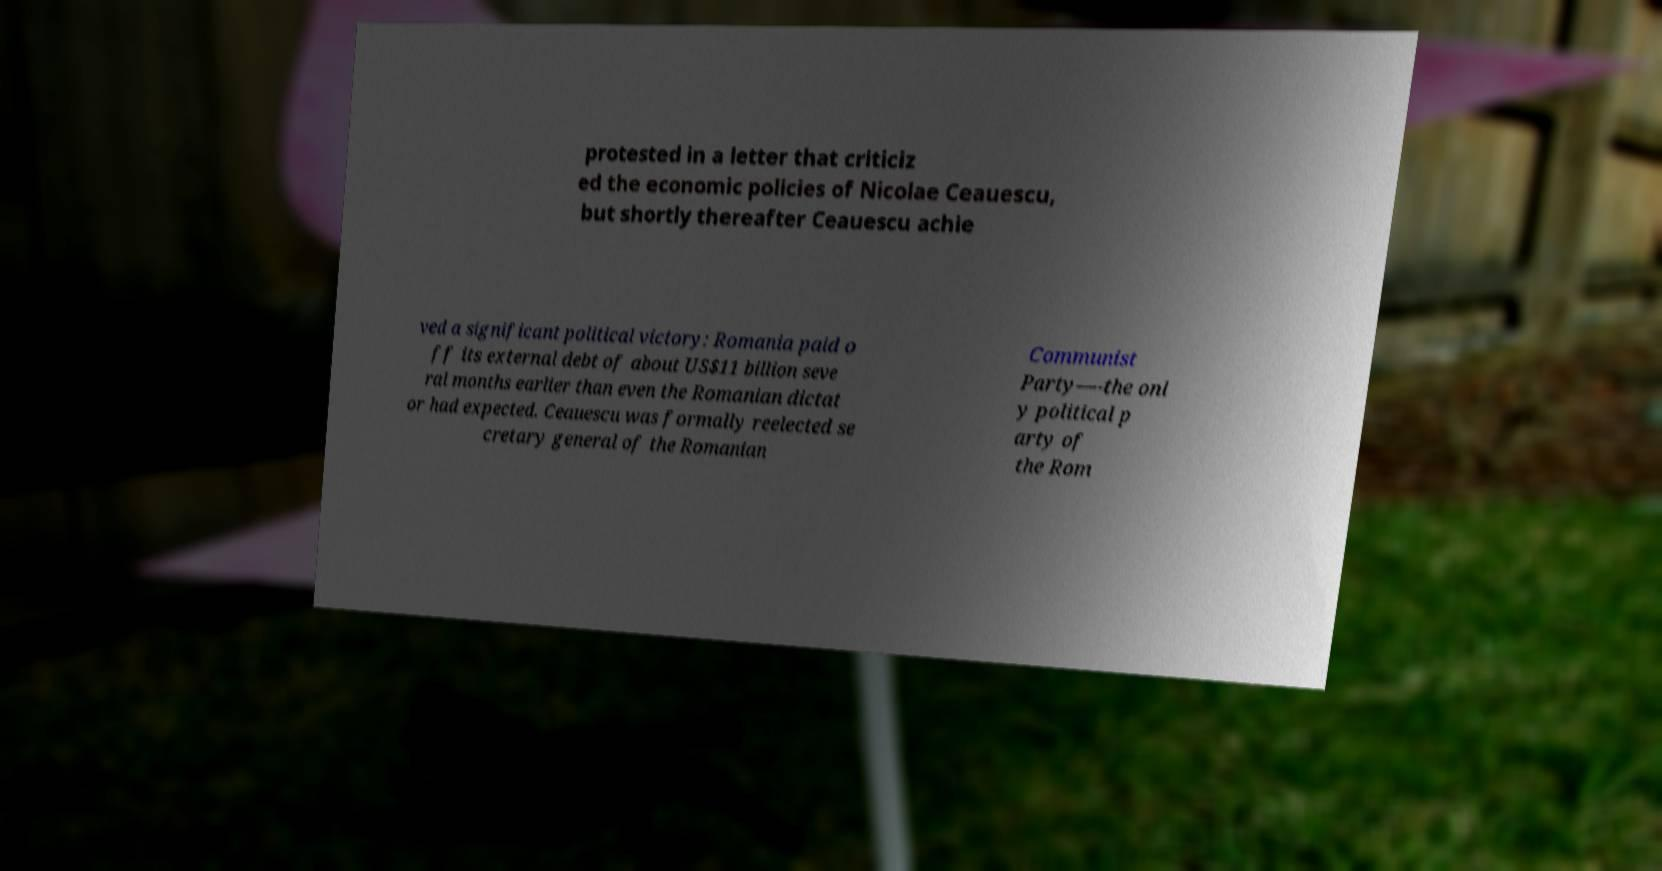Could you extract and type out the text from this image? protested in a letter that criticiz ed the economic policies of Nicolae Ceauescu, but shortly thereafter Ceauescu achie ved a significant political victory: Romania paid o ff its external debt of about US$11 billion seve ral months earlier than even the Romanian dictat or had expected. Ceauescu was formally reelected se cretary general of the Romanian Communist Party—-the onl y political p arty of the Rom 